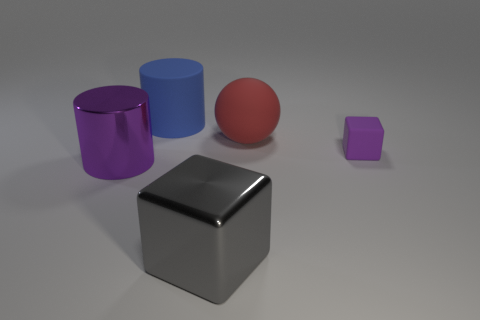Add 3 big purple cylinders. How many objects exist? 8 Subtract all blue cylinders. How many cylinders are left? 1 Subtract all cylinders. How many objects are left? 3 Add 2 gray blocks. How many gray blocks exist? 3 Subtract 1 purple cylinders. How many objects are left? 4 Subtract 1 balls. How many balls are left? 0 Subtract all yellow cylinders. Subtract all yellow blocks. How many cylinders are left? 2 Subtract all red cylinders. How many blue balls are left? 0 Subtract all large cylinders. Subtract all big gray metal cubes. How many objects are left? 2 Add 5 blue rubber cylinders. How many blue rubber cylinders are left? 6 